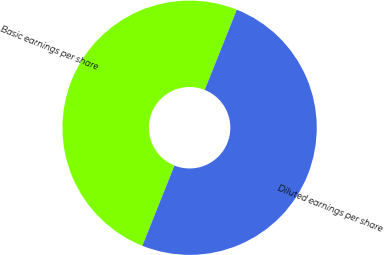Convert chart to OTSL. <chart><loc_0><loc_0><loc_500><loc_500><pie_chart><fcel>Basic earnings per share<fcel>Diluted earnings per share<nl><fcel>50.0%<fcel>50.0%<nl></chart> 